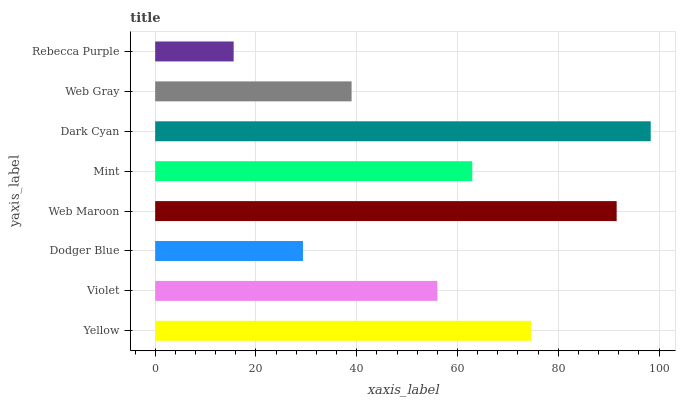Is Rebecca Purple the minimum?
Answer yes or no. Yes. Is Dark Cyan the maximum?
Answer yes or no. Yes. Is Violet the minimum?
Answer yes or no. No. Is Violet the maximum?
Answer yes or no. No. Is Yellow greater than Violet?
Answer yes or no. Yes. Is Violet less than Yellow?
Answer yes or no. Yes. Is Violet greater than Yellow?
Answer yes or no. No. Is Yellow less than Violet?
Answer yes or no. No. Is Mint the high median?
Answer yes or no. Yes. Is Violet the low median?
Answer yes or no. Yes. Is Violet the high median?
Answer yes or no. No. Is Dark Cyan the low median?
Answer yes or no. No. 